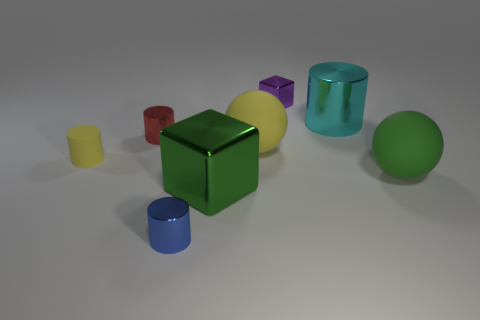What is the size of the cyan object that is the same shape as the small yellow object?
Provide a succinct answer. Large. Are there any cyan matte cubes?
Provide a succinct answer. No. Do the big metal block and the thing to the right of the cyan cylinder have the same color?
Provide a succinct answer. Yes. There is a cube in front of the metallic cylinder right of the big shiny object on the left side of the big yellow matte ball; what size is it?
Ensure brevity in your answer.  Large. What number of big spheres are the same color as the big shiny cube?
Your answer should be very brief. 1. What number of things are either tiny metallic things or shiny things behind the yellow matte sphere?
Offer a very short reply. 4. What color is the large metal block?
Your answer should be compact. Green. What color is the metal cylinder right of the green block?
Give a very brief answer. Cyan. There is a shiny cube to the right of the yellow ball; how many cylinders are behind it?
Keep it short and to the point. 0. Does the purple thing have the same size as the shiny object left of the small blue cylinder?
Offer a very short reply. Yes. 